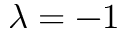<formula> <loc_0><loc_0><loc_500><loc_500>\lambda = - 1</formula> 